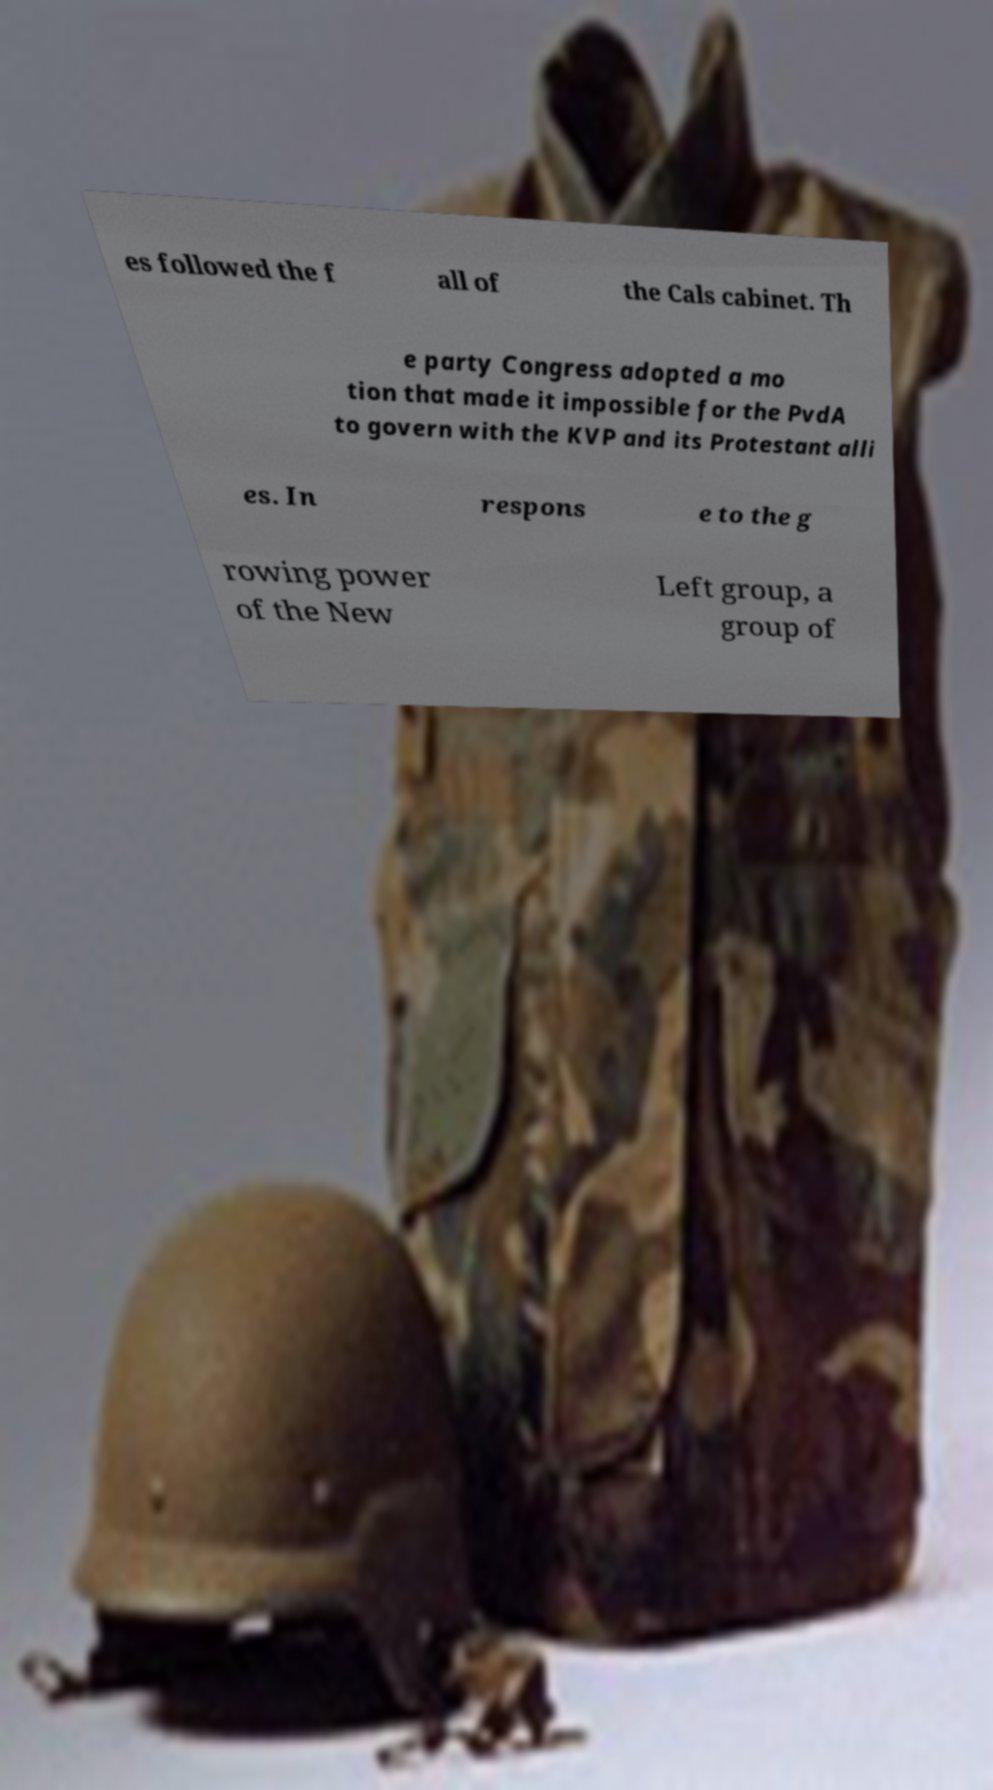I need the written content from this picture converted into text. Can you do that? es followed the f all of the Cals cabinet. Th e party Congress adopted a mo tion that made it impossible for the PvdA to govern with the KVP and its Protestant alli es. In respons e to the g rowing power of the New Left group, a group of 